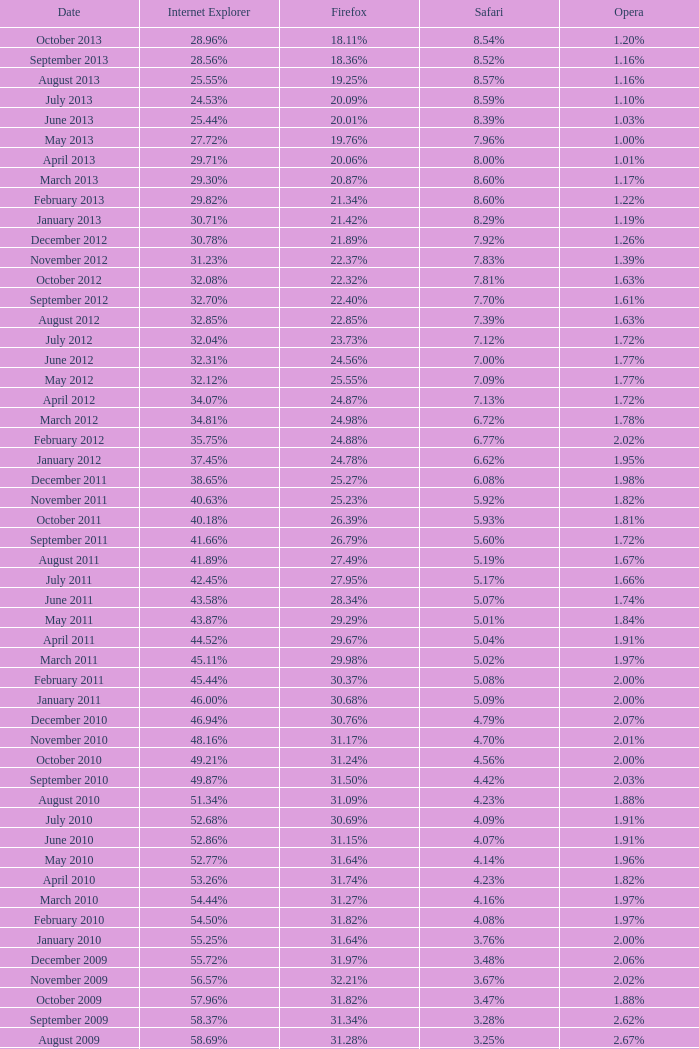What was the usage rate of opera among browsers in november 2009? 2.02%. 